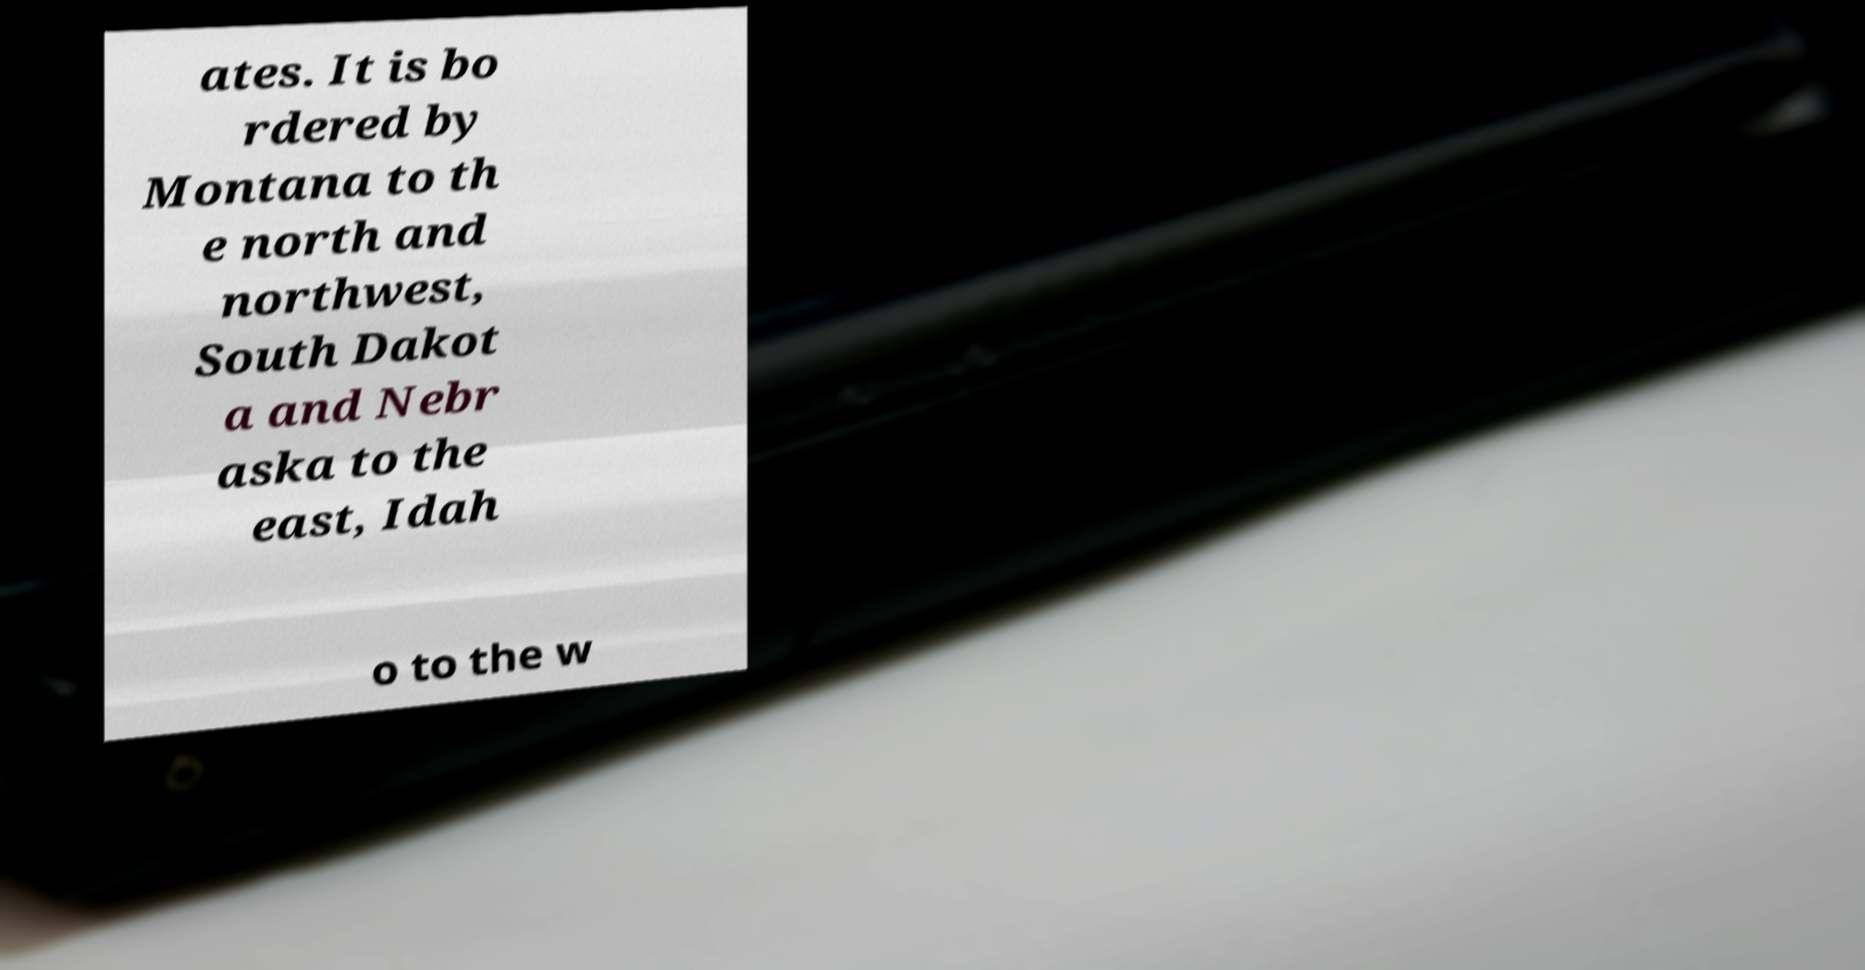For documentation purposes, I need the text within this image transcribed. Could you provide that? ates. It is bo rdered by Montana to th e north and northwest, South Dakot a and Nebr aska to the east, Idah o to the w 